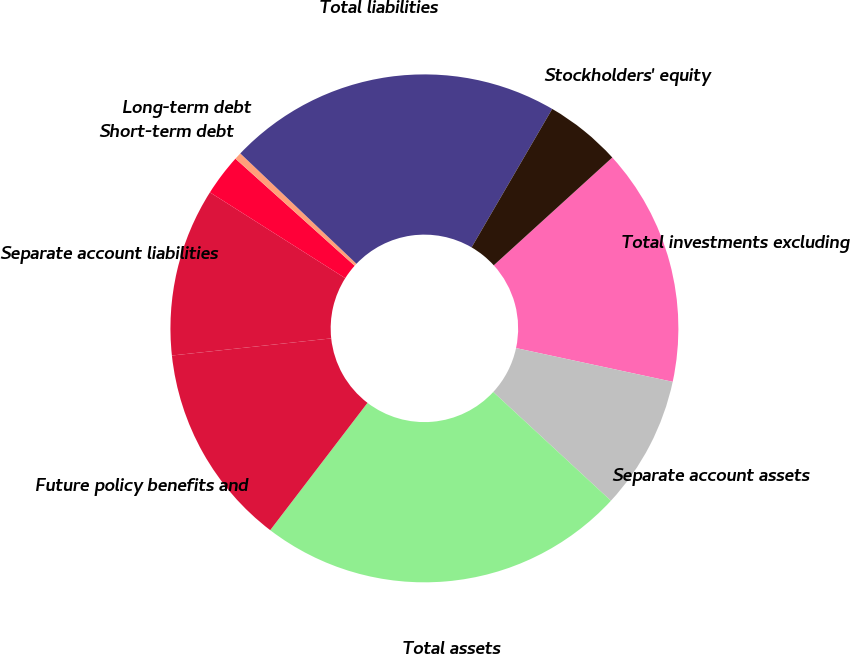<chart> <loc_0><loc_0><loc_500><loc_500><pie_chart><fcel>Total investments excluding<fcel>Separate account assets<fcel>Total assets<fcel>Future policy benefits and<fcel>Separate account liabilities<fcel>Short-term debt<fcel>Long-term debt<fcel>Total liabilities<fcel>Stockholders' equity<nl><fcel>15.12%<fcel>8.5%<fcel>23.51%<fcel>12.91%<fcel>10.7%<fcel>2.65%<fcel>0.45%<fcel>21.3%<fcel>4.86%<nl></chart> 